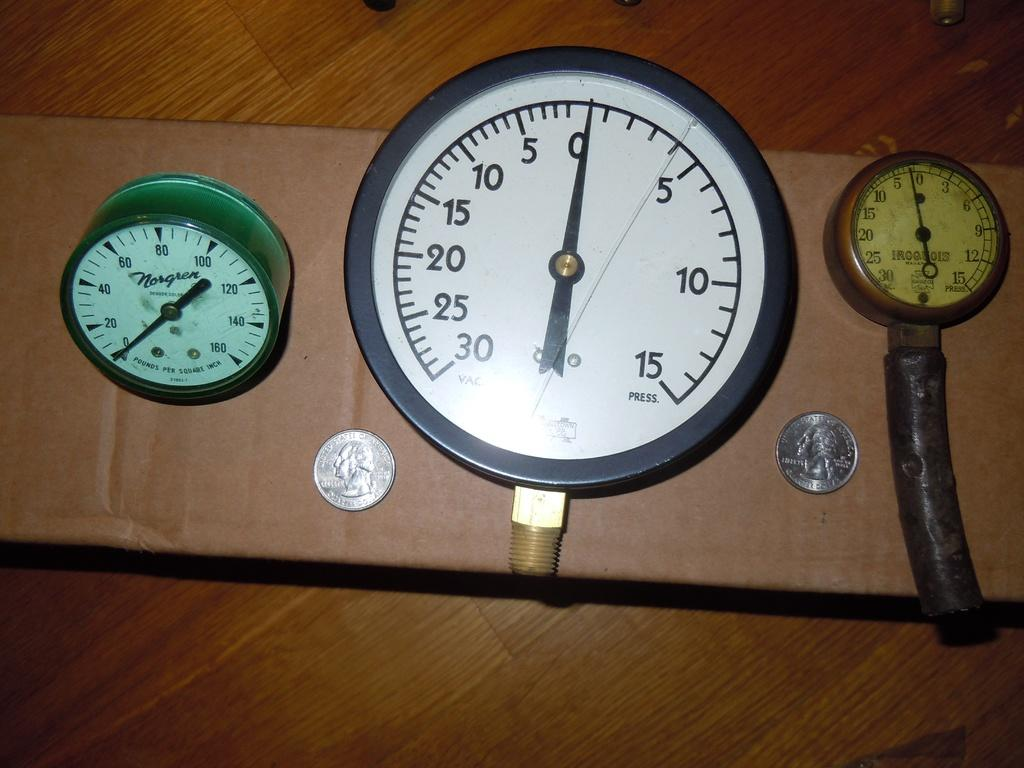Provide a one-sentence caption for the provided image. Three different types of timer clocks with two quarters. 